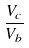Convert formula to latex. <formula><loc_0><loc_0><loc_500><loc_500>\frac { V _ { c } } { V _ { b } }</formula> 